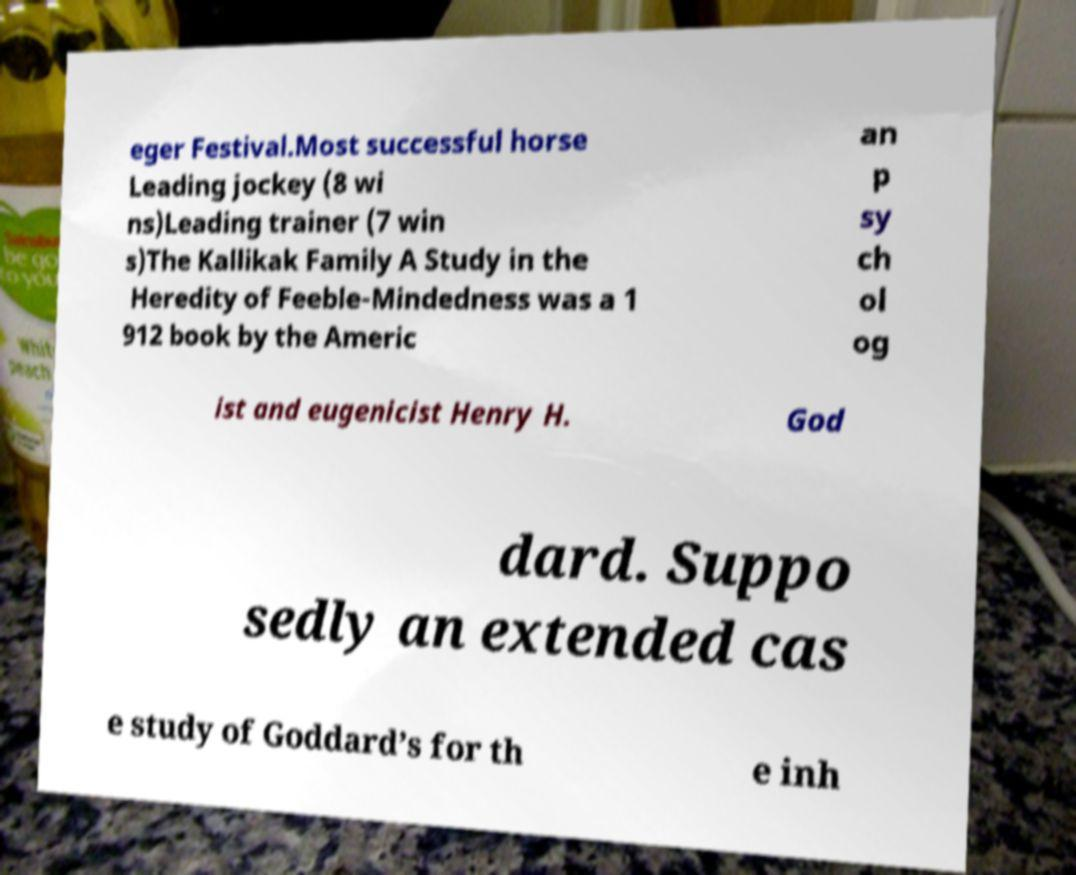Could you extract and type out the text from this image? eger Festival.Most successful horse Leading jockey (8 wi ns)Leading trainer (7 win s)The Kallikak Family A Study in the Heredity of Feeble-Mindedness was a 1 912 book by the Americ an p sy ch ol og ist and eugenicist Henry H. God dard. Suppo sedly an extended cas e study of Goddard’s for th e inh 